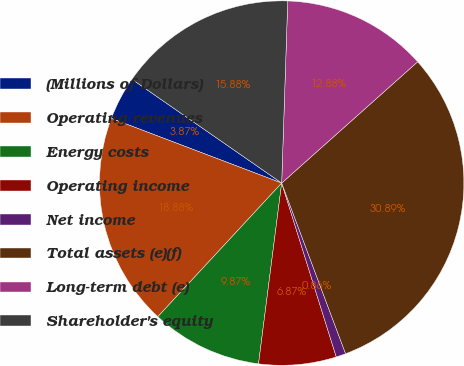Convert chart. <chart><loc_0><loc_0><loc_500><loc_500><pie_chart><fcel>(Millions of Dollars)<fcel>Operating revenues<fcel>Energy costs<fcel>Operating income<fcel>Net income<fcel>Total assets (e)(f)<fcel>Long-term debt (e)<fcel>Shareholder's equity<nl><fcel>3.87%<fcel>18.88%<fcel>9.87%<fcel>6.87%<fcel>0.86%<fcel>30.89%<fcel>12.88%<fcel>15.88%<nl></chart> 